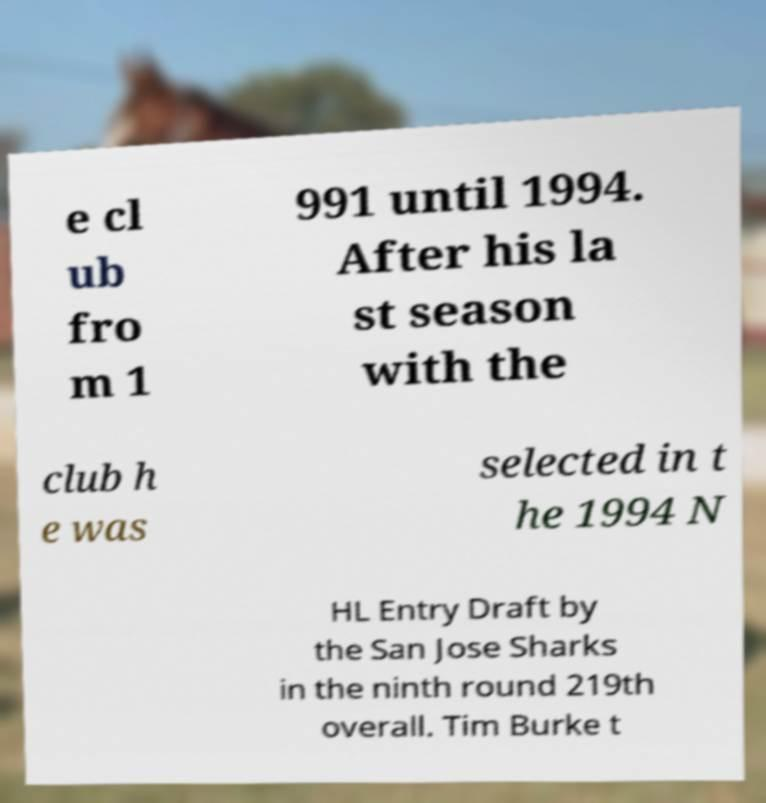Could you assist in decoding the text presented in this image and type it out clearly? e cl ub fro m 1 991 until 1994. After his la st season with the club h e was selected in t he 1994 N HL Entry Draft by the San Jose Sharks in the ninth round 219th overall. Tim Burke t 